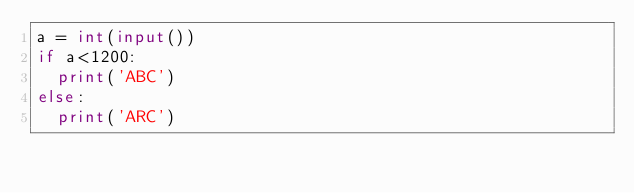<code> <loc_0><loc_0><loc_500><loc_500><_Python_>a = int(input())
if a<1200:
  print('ABC')
else:
  print('ARC')
</code> 